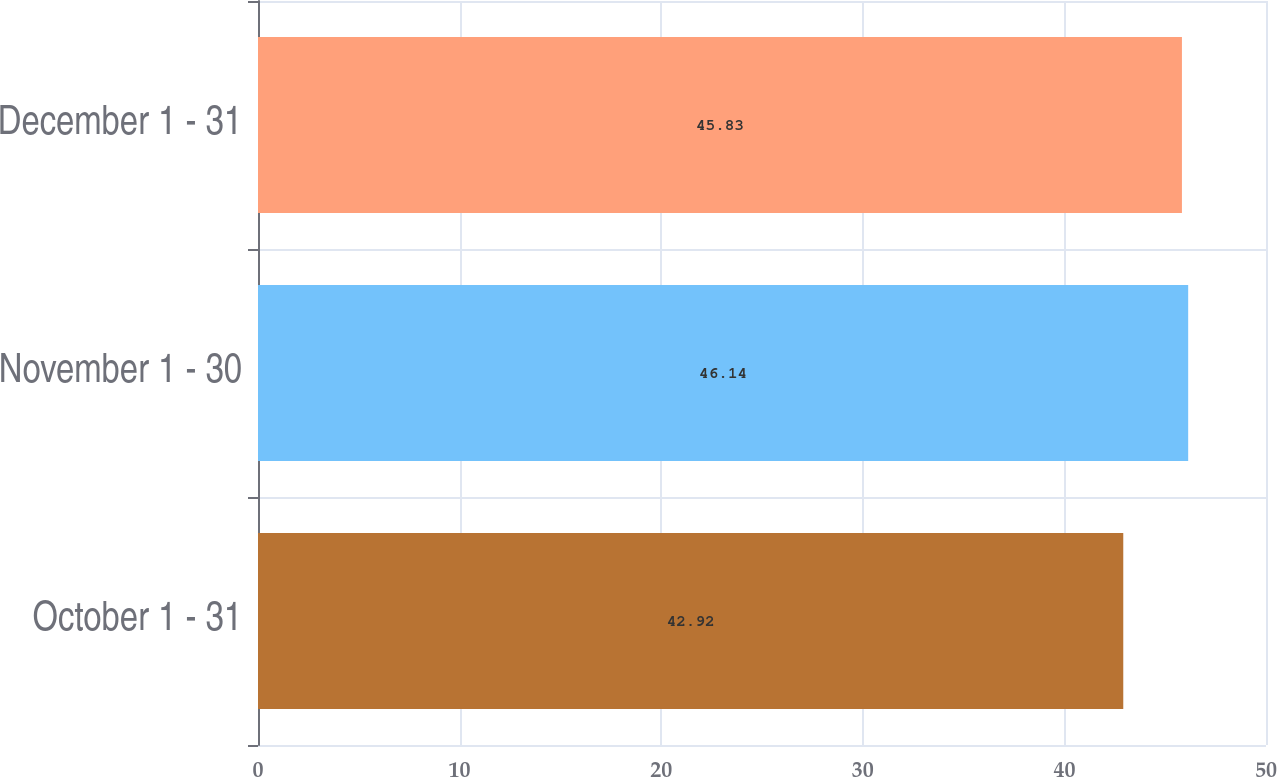<chart> <loc_0><loc_0><loc_500><loc_500><bar_chart><fcel>October 1 - 31<fcel>November 1 - 30<fcel>December 1 - 31<nl><fcel>42.92<fcel>46.14<fcel>45.83<nl></chart> 